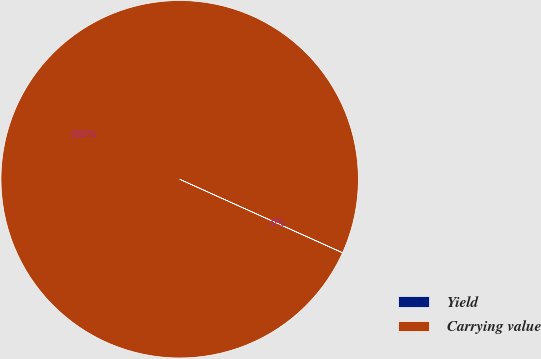<chart> <loc_0><loc_0><loc_500><loc_500><pie_chart><fcel>Yield<fcel>Carrying value<nl><fcel>0.02%<fcel>99.98%<nl></chart> 